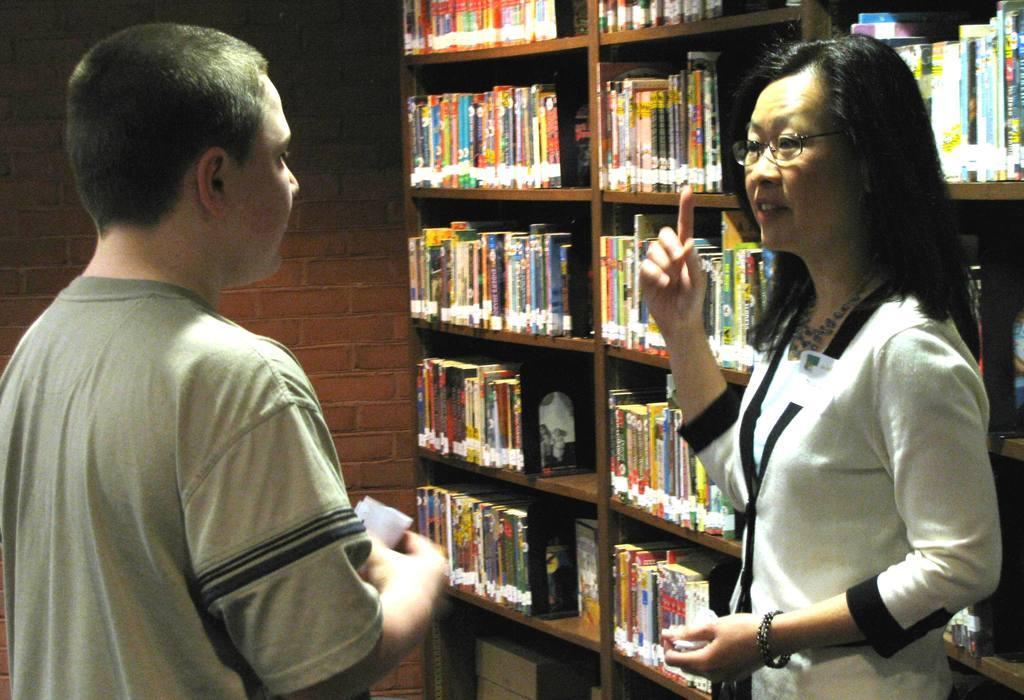In one or two sentences, can you explain what this image depicts? On the right side of the image we can see a lady is standing and talking. On the left side of the image we can see a man is standing and holding a paper. In the background of the image we can see the wall and the rack. In the rack we can see the books. 